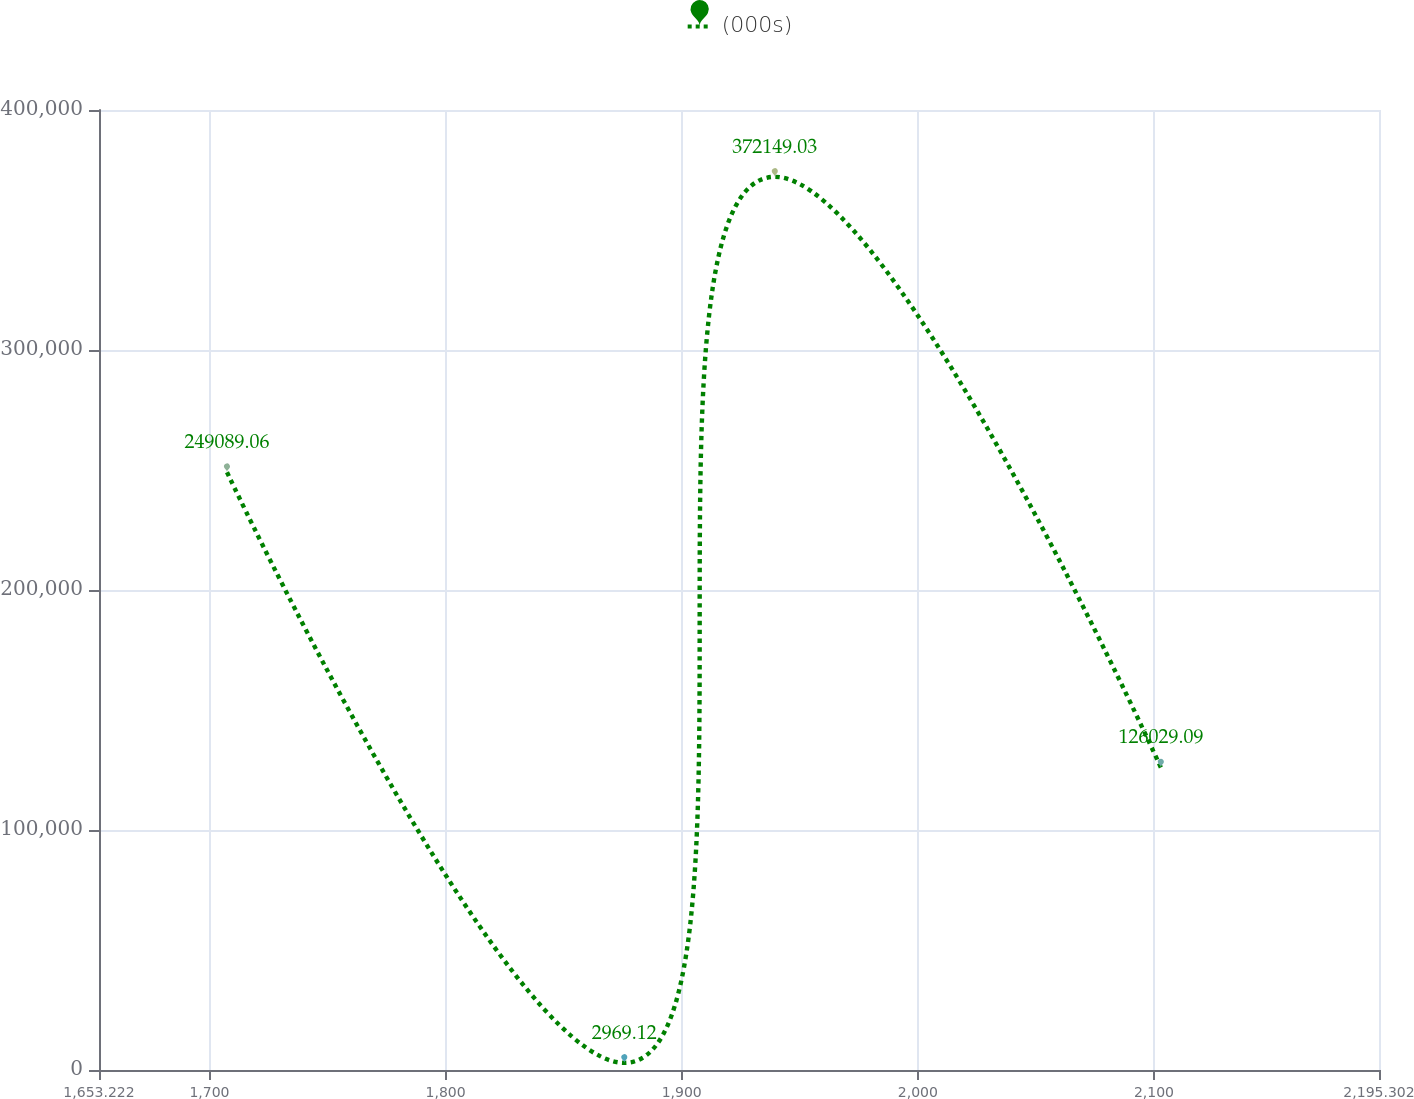Convert chart. <chart><loc_0><loc_0><loc_500><loc_500><line_chart><ecel><fcel>(000s)<nl><fcel>1707.43<fcel>249089<nl><fcel>1875.7<fcel>2969.12<nl><fcel>1939.44<fcel>372149<nl><fcel>2102.93<fcel>126029<nl><fcel>2249.51<fcel>1.23357e+06<nl></chart> 